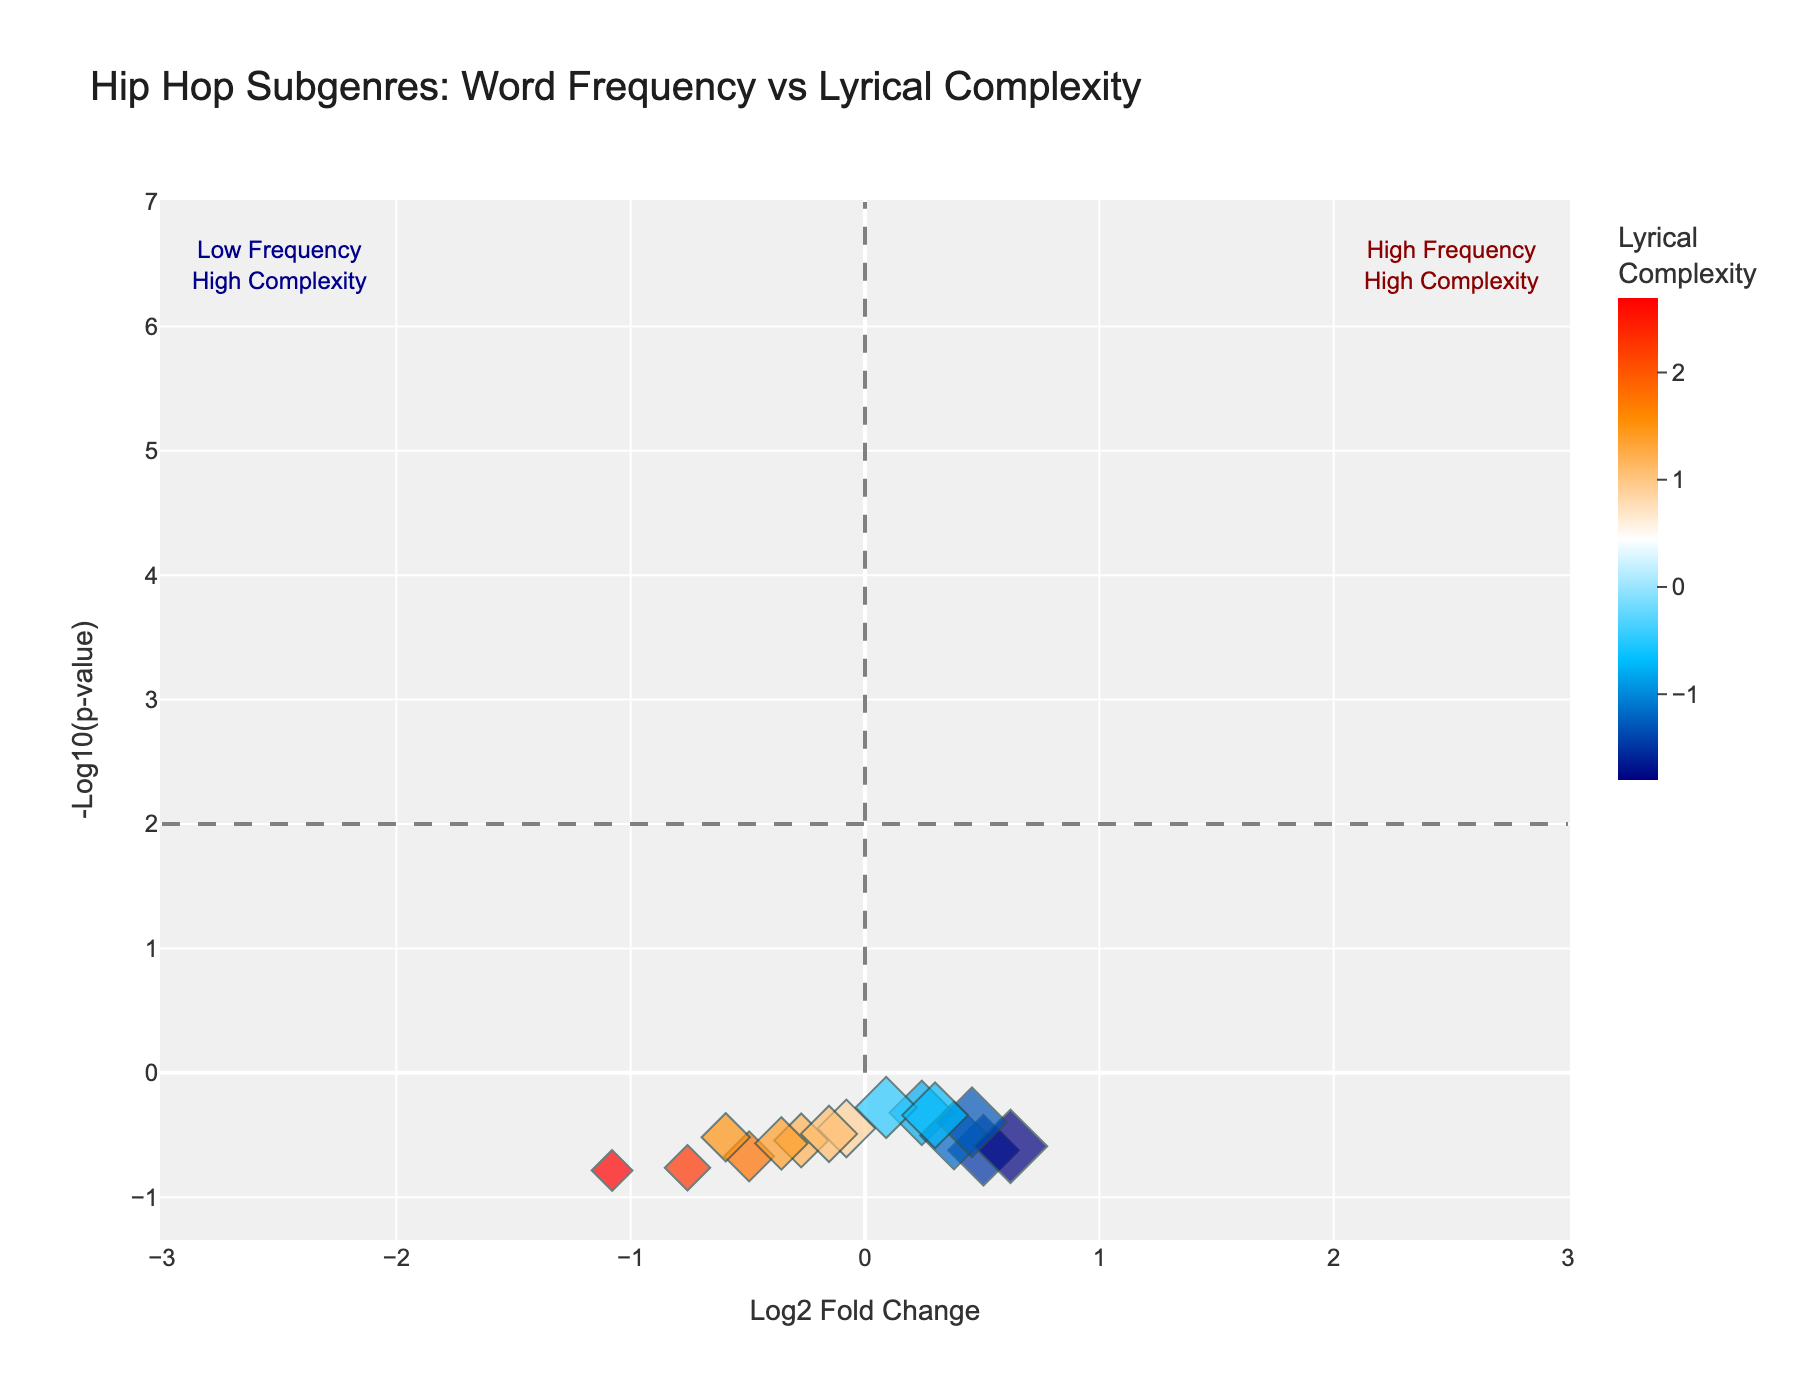What is the title of the plot? The title is usually displayed at the top of the plot in a larger and bolder font than the other text. Here, it reads "Hip Hop Subgenres: Word Frequency vs Lyrical Complexity."
Answer: Hip Hop Subgenres: Word Frequency vs Lyrical Complexity Which subgenre has the highest frequency of words? To find this, look for the point with the largest size. The size of points represents word frequency. The subgenre with the largest point is Gangsta with a WordFrequency of 65.
Answer: Gangsta What does the color of the points represent? The legend on the side often explains what the colors represent. Here, it indicates that the color scale represents "Lyrical Complexity."
Answer: Lyrical Complexity Which subgenre has the highest lyrical complexity? Lyrical complexity can be identified by the color scale. The subgenre with the darkest red color, representing the highest complexity, is Jazz Rap with a LyricalComplexity of 2.7.
Answer: Jazz Rap Which subgenre has the lowest significance value? Significance values are transformed using -log10(p-value). The point with the lowest value on the y-axis represents the lowest significance. Here, the lowest -log10(p-value) value is observed for Melodic with -1.9.
Answer: Melodic What are the axes labels on the plot? The axes labels are written alongside the respective axes. The x-axis is labeled "Log2 Fold Change," and the y-axis is labeled "-Log10(p-value)."
Answer: Log2 Fold Change (x-axis) and -Log10(p-value) (y-axis) How many subgenres lie in the high frequency and high complexity quadrant? The high frequency and high complexity quadrant is represented by points in the top right section. There is an annotation "High Frequency\nHigh Complexity" to help identify it. The subgenres in this quadrant are Lyrical and Jazz Rap.
Answer: Two Compare the word frequency between Mumble Rap and Conscious hip hop. Locate the points for Mumble Rap and Conscious on the plot. Mumble Rap has a word frequency of 60, while Conscious has a word frequency of 35. 60 (Mumble Rap) is greater than 35 (Conscious).
Answer: Mumble Rap > Conscious If the average log2 fold change is 0, which subgenres have a positive log2 fold change? Positive log2 fold change values are those on the right side of the vertical line at x=0. The subgenres with positive log2 fold change are Conscious, Lyrical, Political, Jazz Rap, Alternative, and East Coast.
Answer: Six subgenres What does the dashed horizontal line at y=2 represent? The plot have custom shapes for significance thresholds. The dashed horizontal line at y=2 is often used to indicate a fixed p-value threshold. Here, it helps identify significantly low p-values.
Answer: Significance threshold indicator 